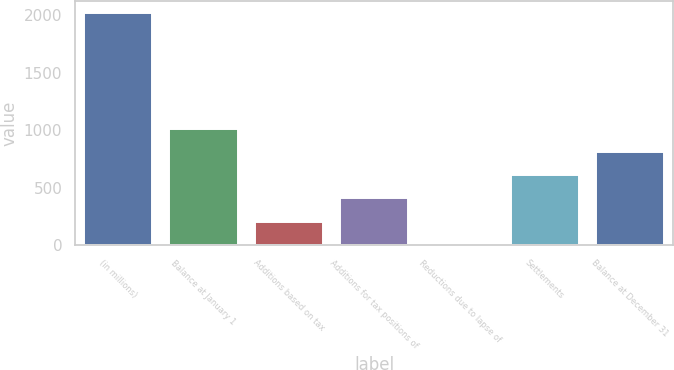<chart> <loc_0><loc_0><loc_500><loc_500><bar_chart><fcel>(in millions)<fcel>Balance at January 1<fcel>Additions based on tax<fcel>Additions for tax positions of<fcel>Reductions due to lapse of<fcel>Settlements<fcel>Balance at December 31<nl><fcel>2018<fcel>1010.5<fcel>204.5<fcel>406<fcel>3<fcel>607.5<fcel>809<nl></chart> 